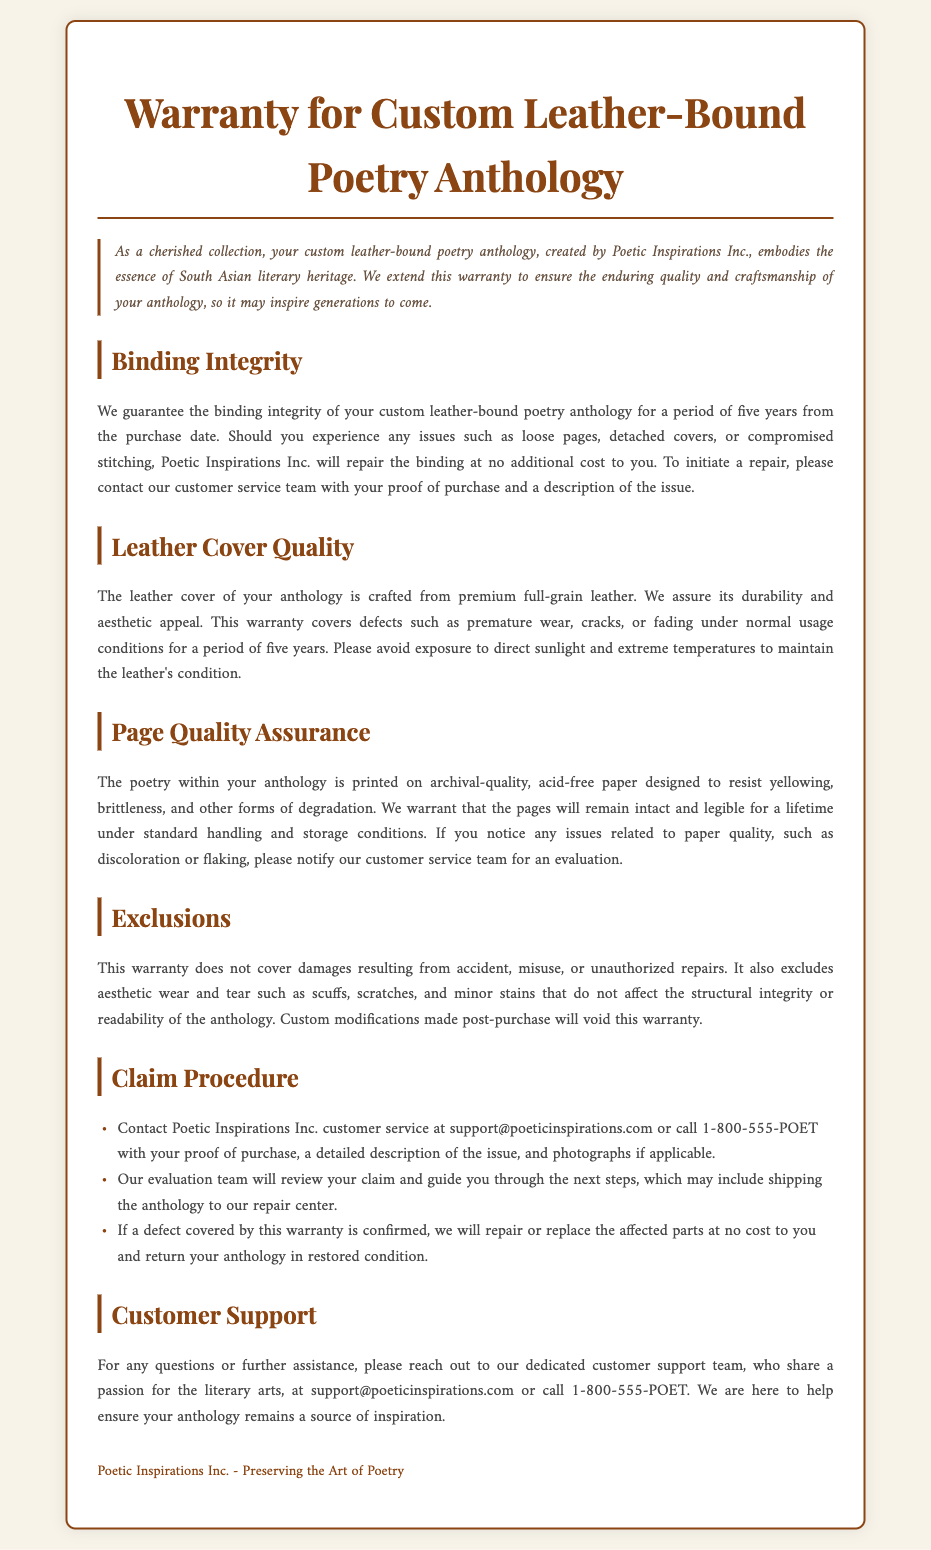What is the warranty period for binding integrity? The warranty period for binding integrity is stated in the document as five years from the purchase date.
Answer: five years What type of leather is used for the anthology cover? The document specifies that the leather cover is crafted from premium full-grain leather.
Answer: full-grain leather Under what conditions should you avoid exposing the leather cover? The document mentions that exposure to direct sunlight and extreme temperatures should be avoided to maintain the leather's condition.
Answer: direct sunlight and extreme temperatures What type of paper is used for printing the poetry? The warranty describes the paper as archival-quality and acid-free, which is designed to resist yellowing and brittleness.
Answer: archival-quality, acid-free What must you provide to initiate a repair claim? The document states that you need to provide your proof of purchase and a description of the issue to initiate a repair claim.
Answer: proof of purchase and description of the issue What is excluded from the warranty coverage? The warranty excludes damages resulting from accident, misuse, or unauthorized repairs.
Answer: damages from accident, misuse, or unauthorized repairs How can you contact customer support? The document provides a contact email and phone number for customer support: support@poeticinspirations.com or call 1-800-555-POET.
Answer: support@poeticinspirations.com or call 1-800-555-POET What is the warranty duration for page quality assurance? The document states that the pages will remain intact and legible for a lifetime under standard handling and storage conditions.
Answer: a lifetime What may void the warranty? The warranty may be voided by custom modifications made post-purchase.
Answer: custom modifications made post-purchase 